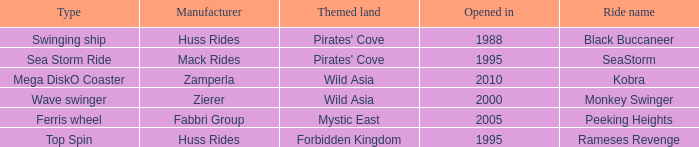Which ride opened after the 2000 Peeking Heights? Ferris wheel. 